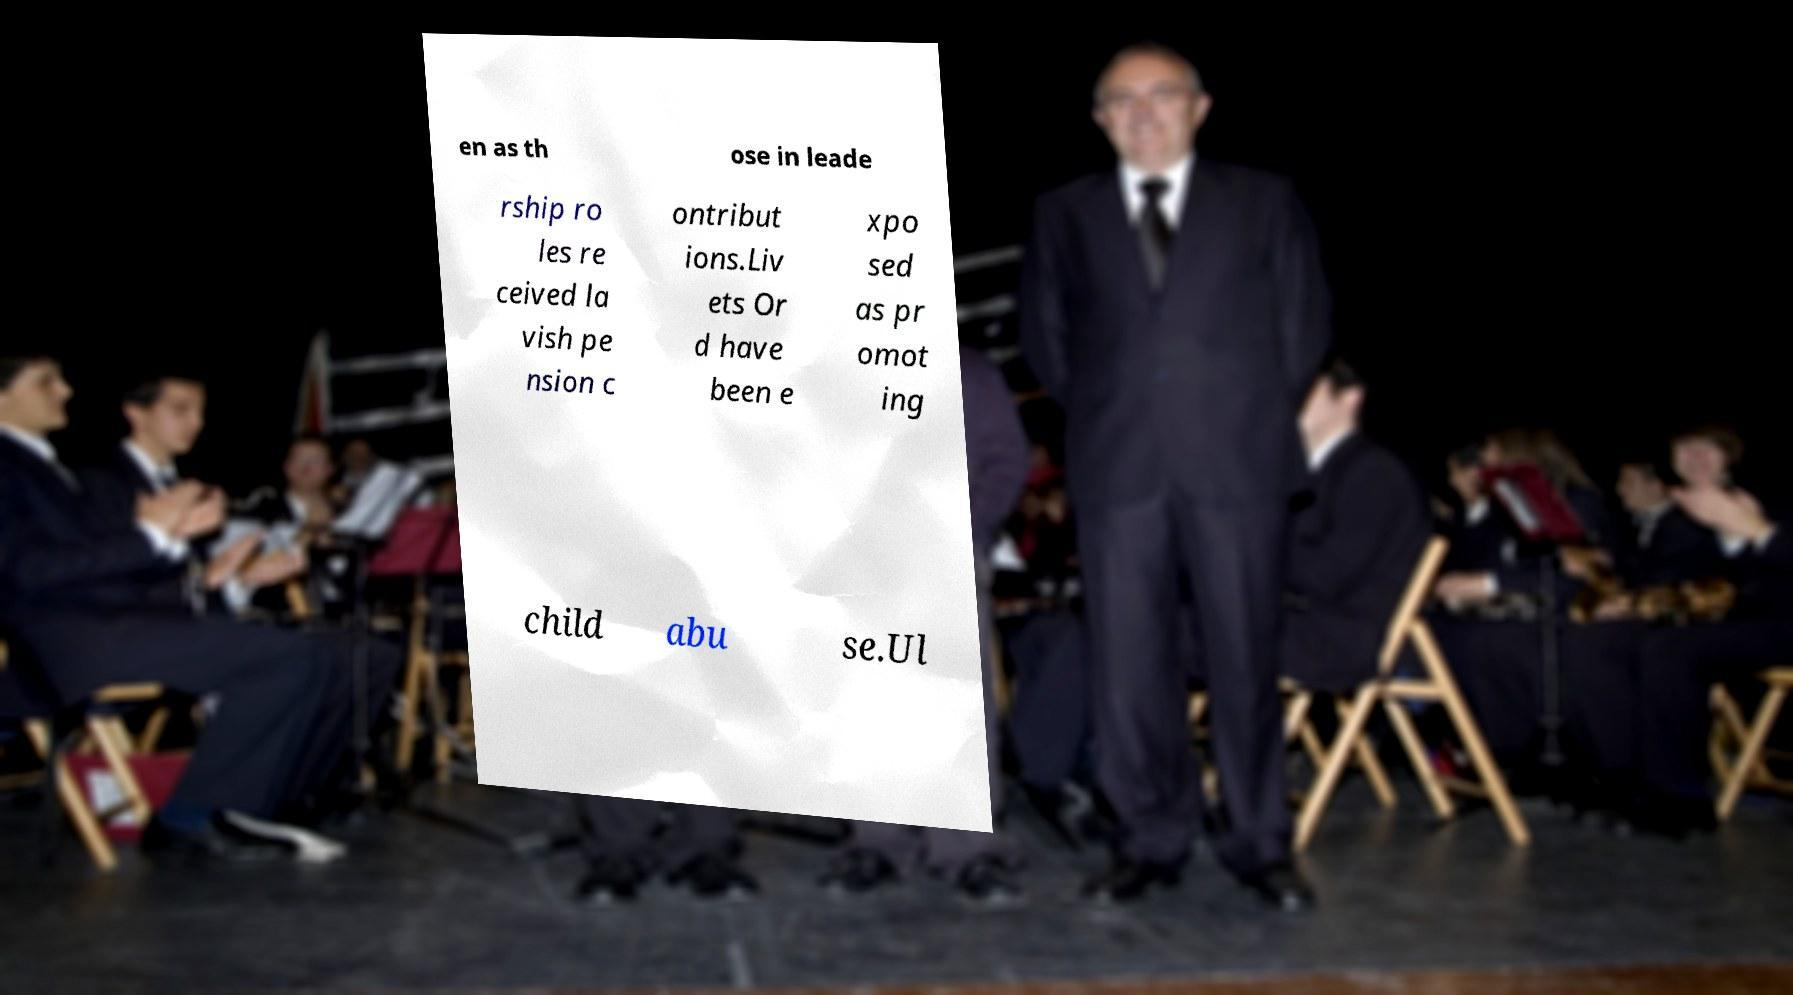What messages or text are displayed in this image? I need them in a readable, typed format. en as th ose in leade rship ro les re ceived la vish pe nsion c ontribut ions.Liv ets Or d have been e xpo sed as pr omot ing child abu se.Ul 